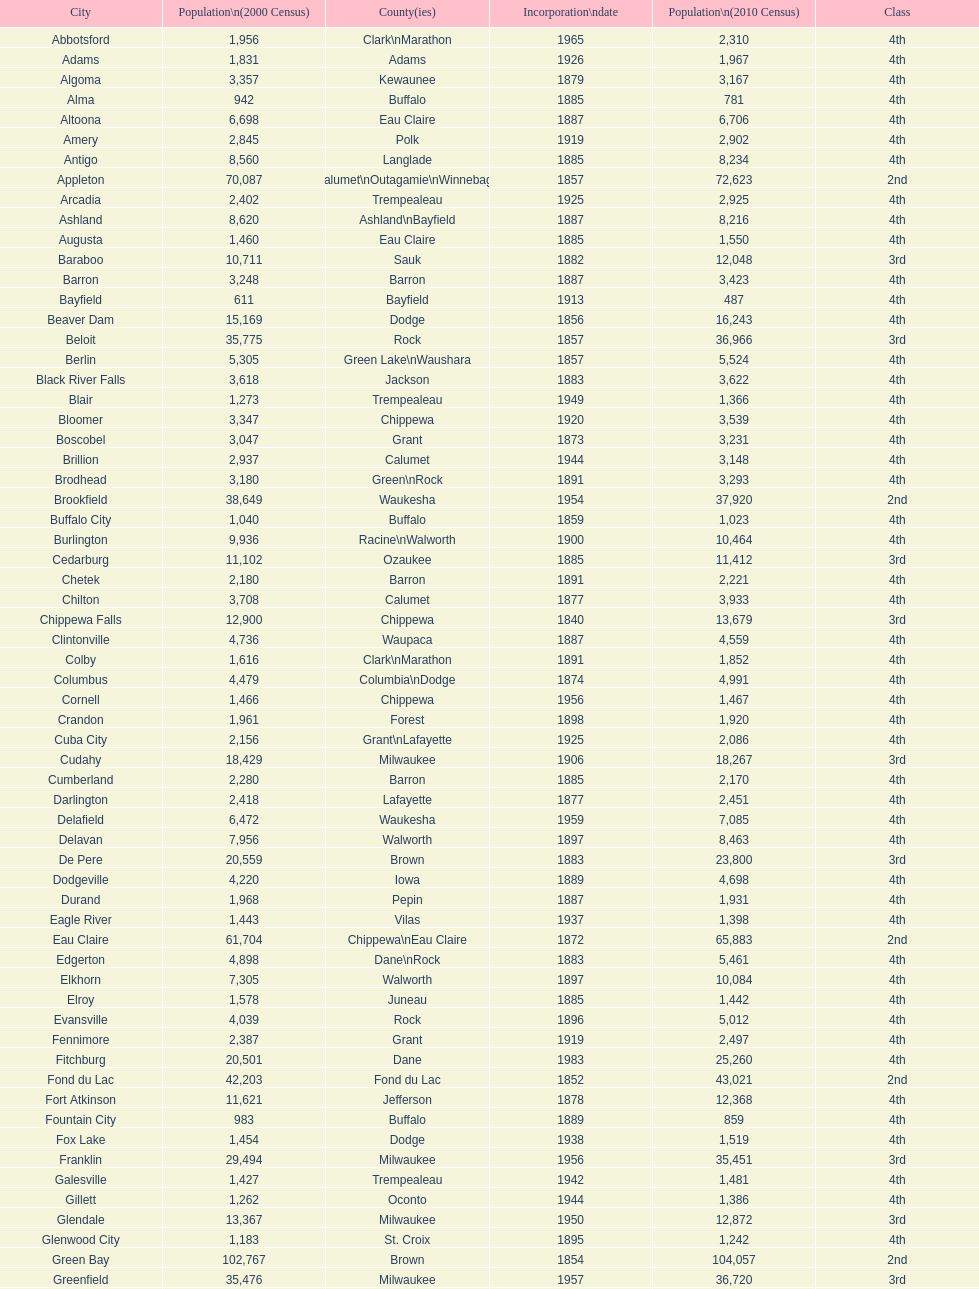What was the first city to be incorporated into wisconsin? Chippewa Falls. 